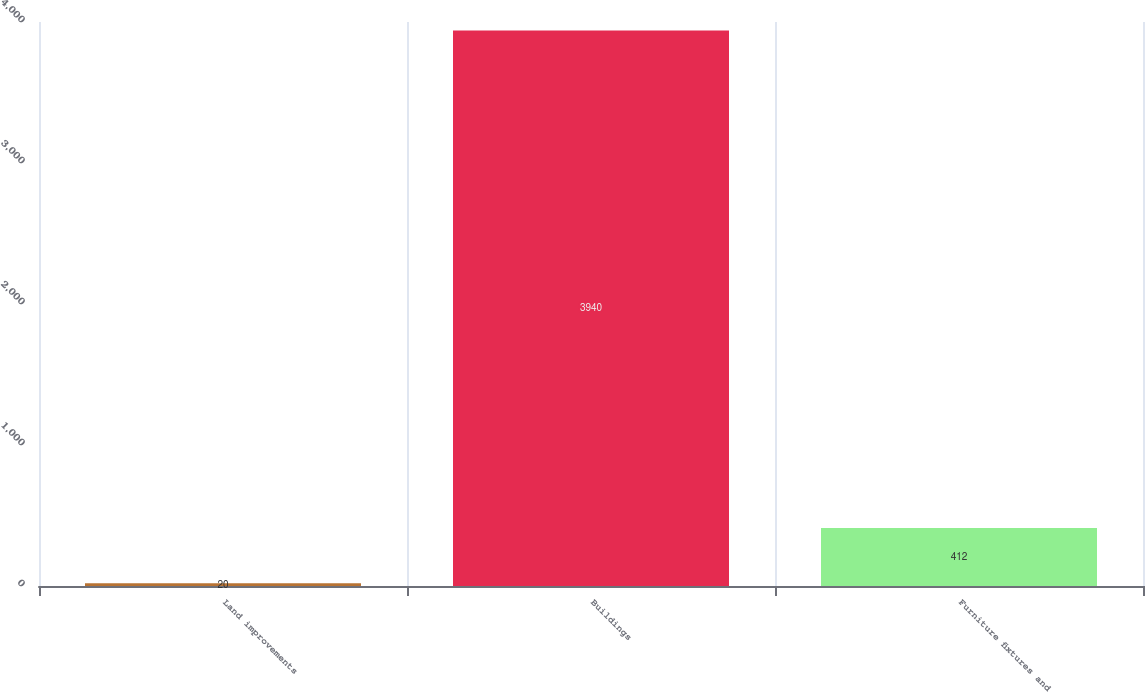Convert chart. <chart><loc_0><loc_0><loc_500><loc_500><bar_chart><fcel>Land improvements<fcel>Buildings<fcel>Furniture fixtures and<nl><fcel>20<fcel>3940<fcel>412<nl></chart> 